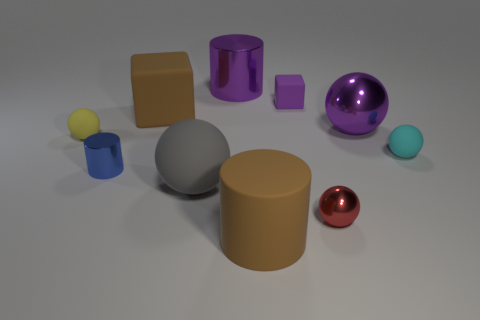What is the material of the small yellow sphere on the left side of the large purple shiny thing behind the large brown block behind the tiny blue cylinder? Based on the visual cues from the image, the small yellow sphere is likely made of a matte plastic material. Its surface lacks the reflections typically associated with metallic or glass objects, suggesting a less reflective material such as plastic. 